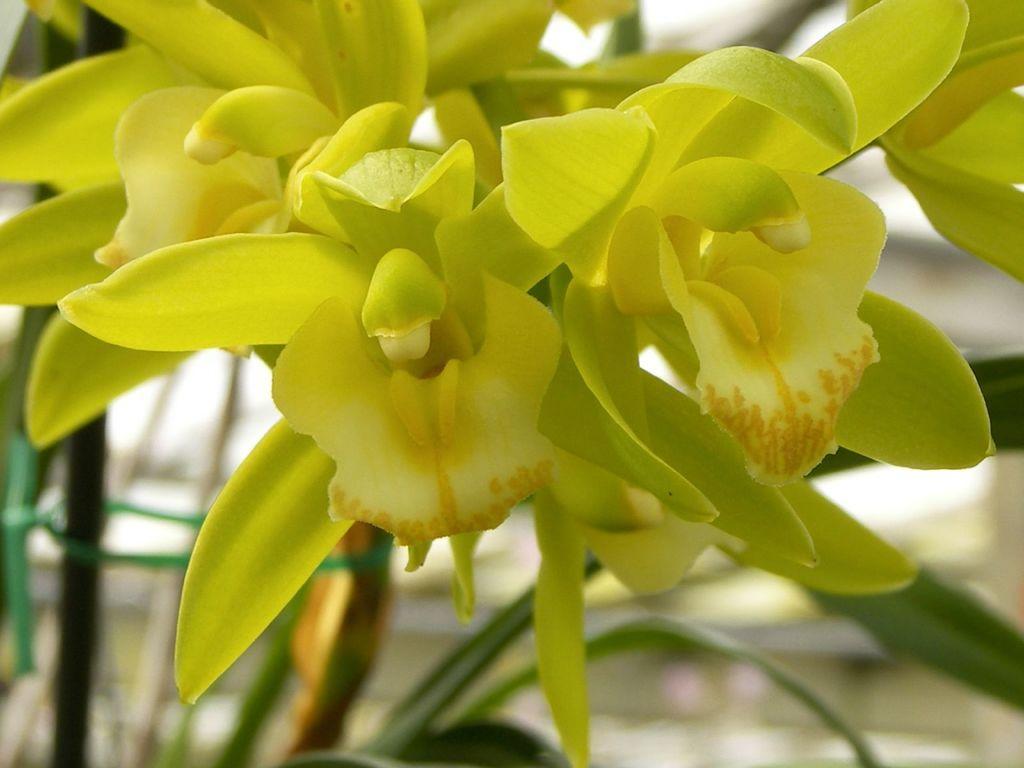Please provide a concise description of this image. In this picture we can see flowers and in the background we can see leaves, some objects and it is blurry. 